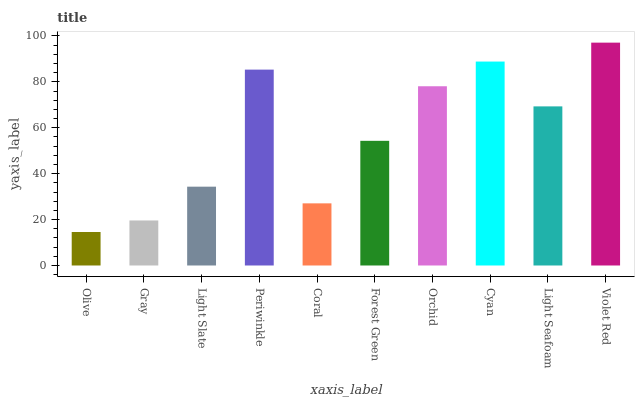Is Olive the minimum?
Answer yes or no. Yes. Is Violet Red the maximum?
Answer yes or no. Yes. Is Gray the minimum?
Answer yes or no. No. Is Gray the maximum?
Answer yes or no. No. Is Gray greater than Olive?
Answer yes or no. Yes. Is Olive less than Gray?
Answer yes or no. Yes. Is Olive greater than Gray?
Answer yes or no. No. Is Gray less than Olive?
Answer yes or no. No. Is Light Seafoam the high median?
Answer yes or no. Yes. Is Forest Green the low median?
Answer yes or no. Yes. Is Cyan the high median?
Answer yes or no. No. Is Cyan the low median?
Answer yes or no. No. 